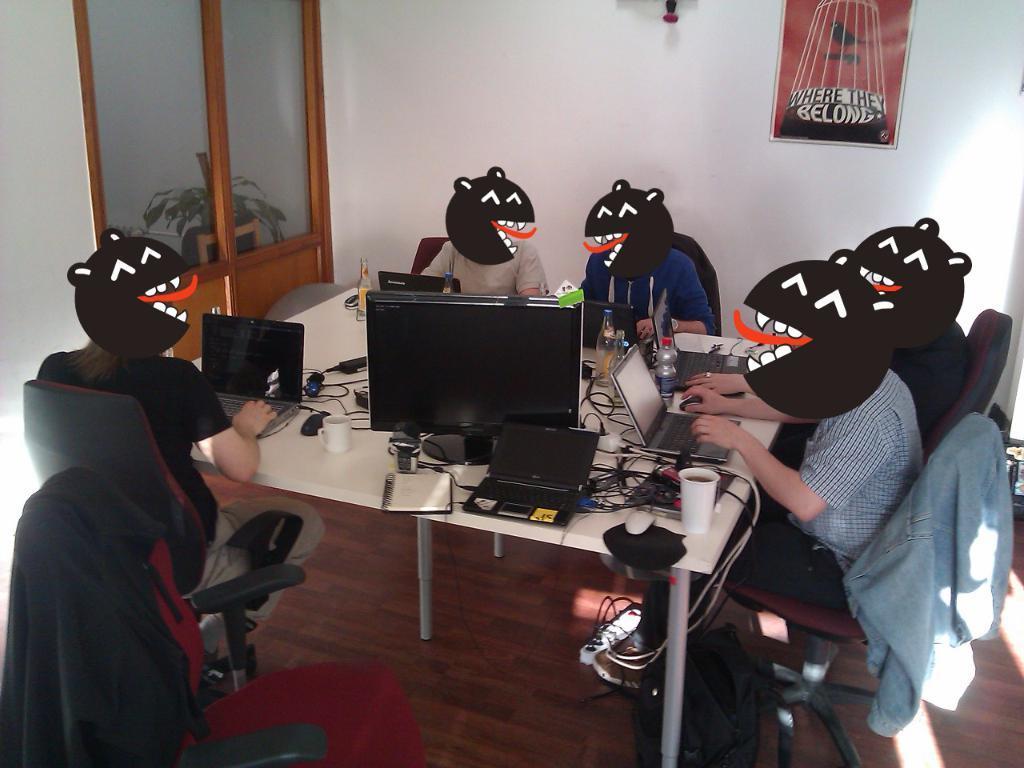How would you summarize this image in a sentence or two? In this image i can see there are group of people who are sitting on a chair in front of table. On the table i can see there is a laptop and other objects on it. 